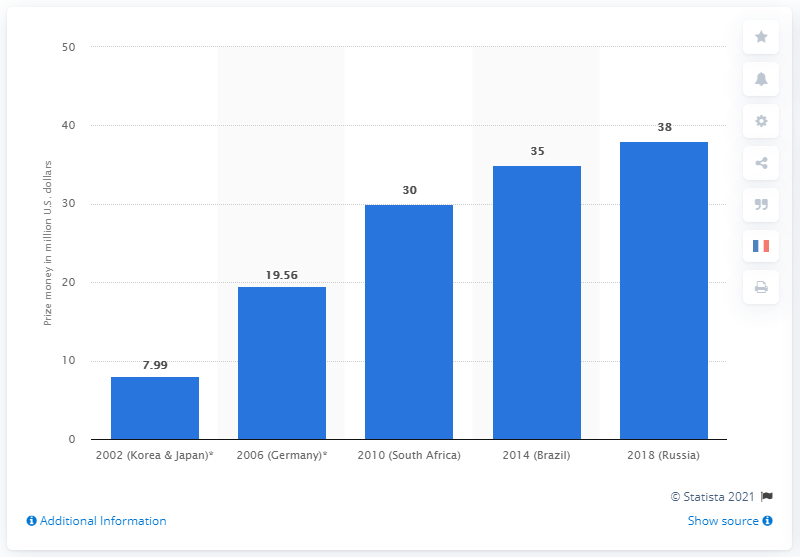Outline some significant characteristics in this image. The winner of the 2014 FIFA World Cup was awarded a total of 35 million dollars. 